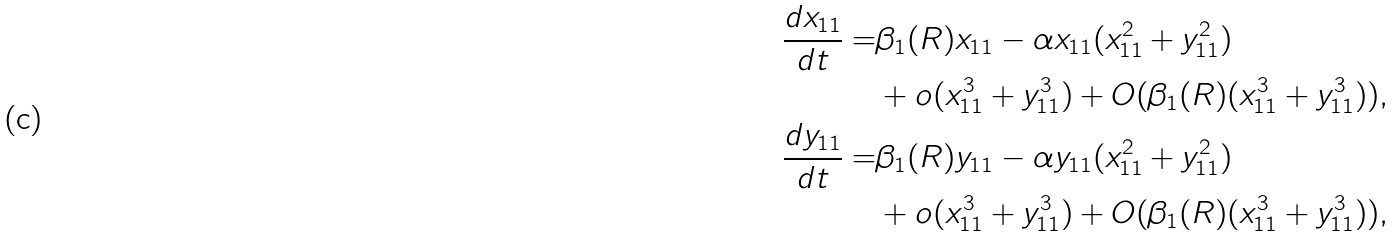Convert formula to latex. <formula><loc_0><loc_0><loc_500><loc_500>\frac { d x _ { 1 1 } } { d t } = & \beta _ { 1 } ( R ) x _ { 1 1 } - \alpha x _ { 1 1 } ( x _ { 1 1 } ^ { 2 } + y _ { 1 1 } ^ { 2 } ) \\ & + o ( x _ { 1 1 } ^ { 3 } + y _ { 1 1 } ^ { 3 } ) + O ( \beta _ { 1 } ( R ) ( x _ { 1 1 } ^ { 3 } + y _ { 1 1 } ^ { 3 } ) ) , \\ \frac { d y _ { 1 1 } } { d t } = & \beta _ { 1 } ( R ) y _ { 1 1 } - \alpha y _ { 1 1 } ( x _ { 1 1 } ^ { 2 } + y _ { 1 1 } ^ { 2 } ) \\ & + o ( x _ { 1 1 } ^ { 3 } + y _ { 1 1 } ^ { 3 } ) + O ( \beta _ { 1 } ( R ) ( x _ { 1 1 } ^ { 3 } + y _ { 1 1 } ^ { 3 } ) ) ,</formula> 